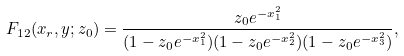Convert formula to latex. <formula><loc_0><loc_0><loc_500><loc_500>F _ { 1 2 } ( x _ { r } , y ; z _ { 0 } ) = \frac { z _ { 0 } e ^ { - x _ { 1 } ^ { 2 } } } { ( 1 - z _ { 0 } e ^ { - x _ { 1 } ^ { 2 } } ) ( 1 - z _ { 0 } e ^ { - x _ { 2 } ^ { 2 } } ) ( 1 - z _ { 0 } e ^ { - x _ { 3 } ^ { 2 } } ) } ,</formula> 